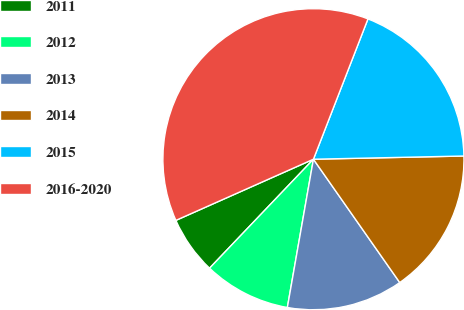Convert chart. <chart><loc_0><loc_0><loc_500><loc_500><pie_chart><fcel>2011<fcel>2012<fcel>2013<fcel>2014<fcel>2015<fcel>2016-2020<nl><fcel>6.22%<fcel>9.35%<fcel>12.49%<fcel>15.62%<fcel>18.76%<fcel>37.56%<nl></chart> 